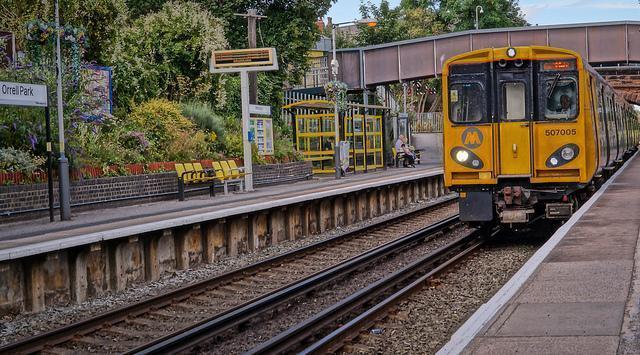How many train tracks do you see?
Give a very brief answer. 2. How many trains are in the image?
Give a very brief answer. 1. How many black horse are there in the image ?
Give a very brief answer. 0. 